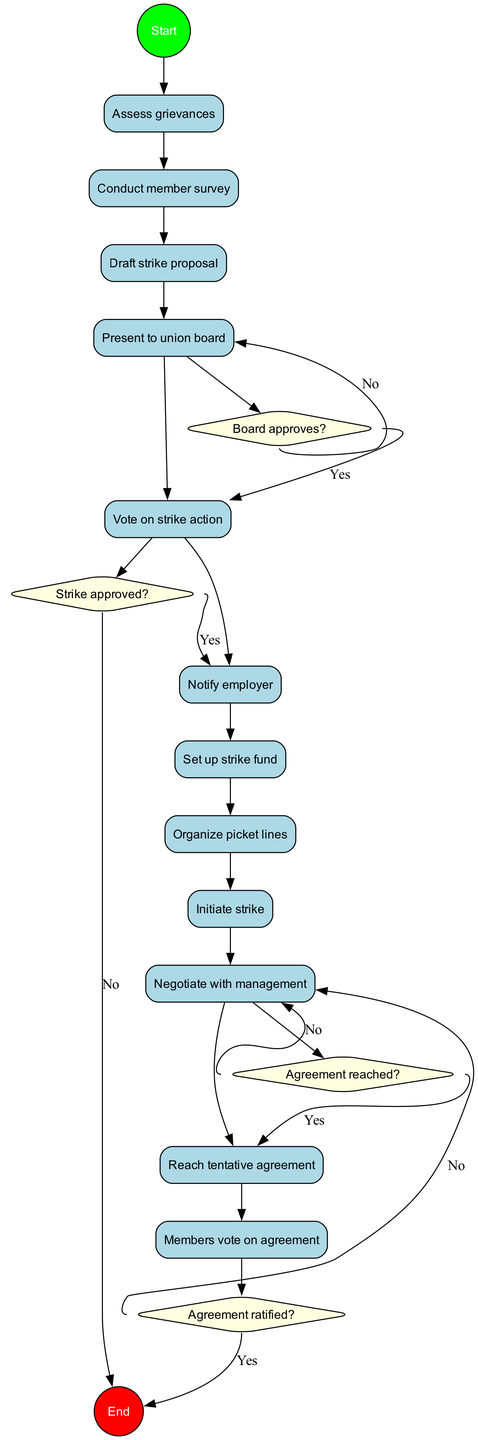What is the starting point of the diagram? The starting point of the diagram is indicated by the 'Start' node, which represents the initial action of receiving worker complaints.
Answer: Receive worker complaints How many activities are listed in the diagram? The diagram includes a total of 12 activities ranging from assessing grievances to members voting on the agreement.
Answer: 12 What happens after the 'Draft strike proposal' activity? Following the 'Draft strike proposal' activity, the next step is to 'Present to union board'. This connection can be traced directly from the sequence of activities.
Answer: Present to union board What is the result if the board does not approve the proposal? If the board does not approve the proposal as indicated by the 'Board approves?' decision node, the next action will be to 'Revise proposal'.
Answer: Revise proposal What decision follows the 'Initiate strike' activity? After the 'Initiate strike' activity, the subsequent decision is 'Agreement reached?', determining whether negotiations are successful or if they need to continue.
Answer: Agreement reached? What occurs if the agreement is ratified? If the agreement is ratified, as indicated in the 'Agreement ratified?' decision node, the process ends with 'End strike'. This suggests that the strike will conclude upon successful ratification.
Answer: End strike How many decision nodes are present in the diagram? There are a total of four decision nodes, each representing a choice that affects the process flow related to strike actions and agreement outcomes.
Answer: 4 What is the end point of the diagram? The end point of the activity diagram is signified by the 'End' node, which represents the final stage of implementing the new contract following successful negotiations.
Answer: Implement new contract 